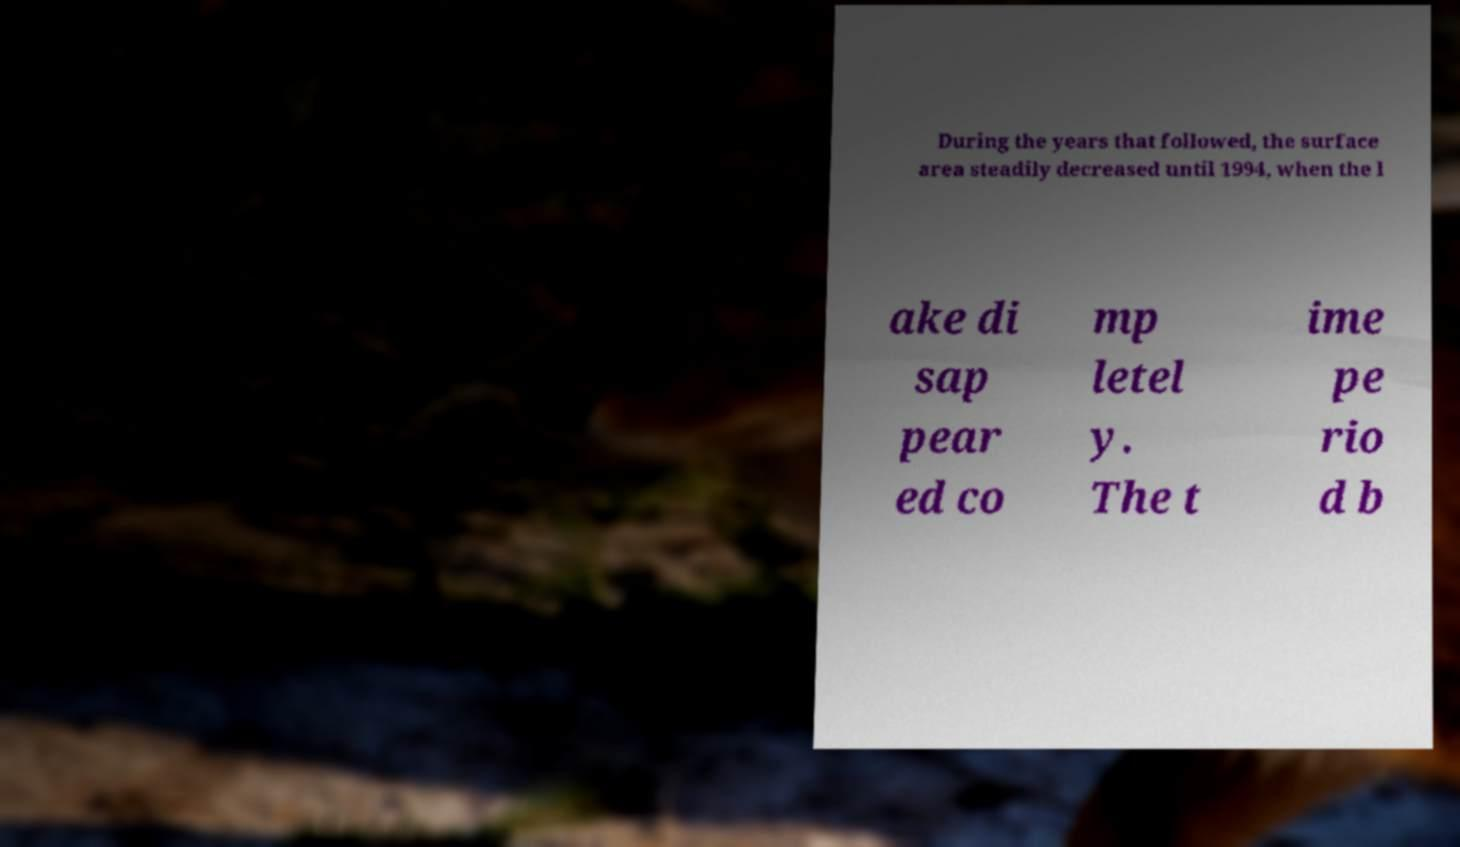Can you accurately transcribe the text from the provided image for me? During the years that followed, the surface area steadily decreased until 1994, when the l ake di sap pear ed co mp letel y. The t ime pe rio d b 